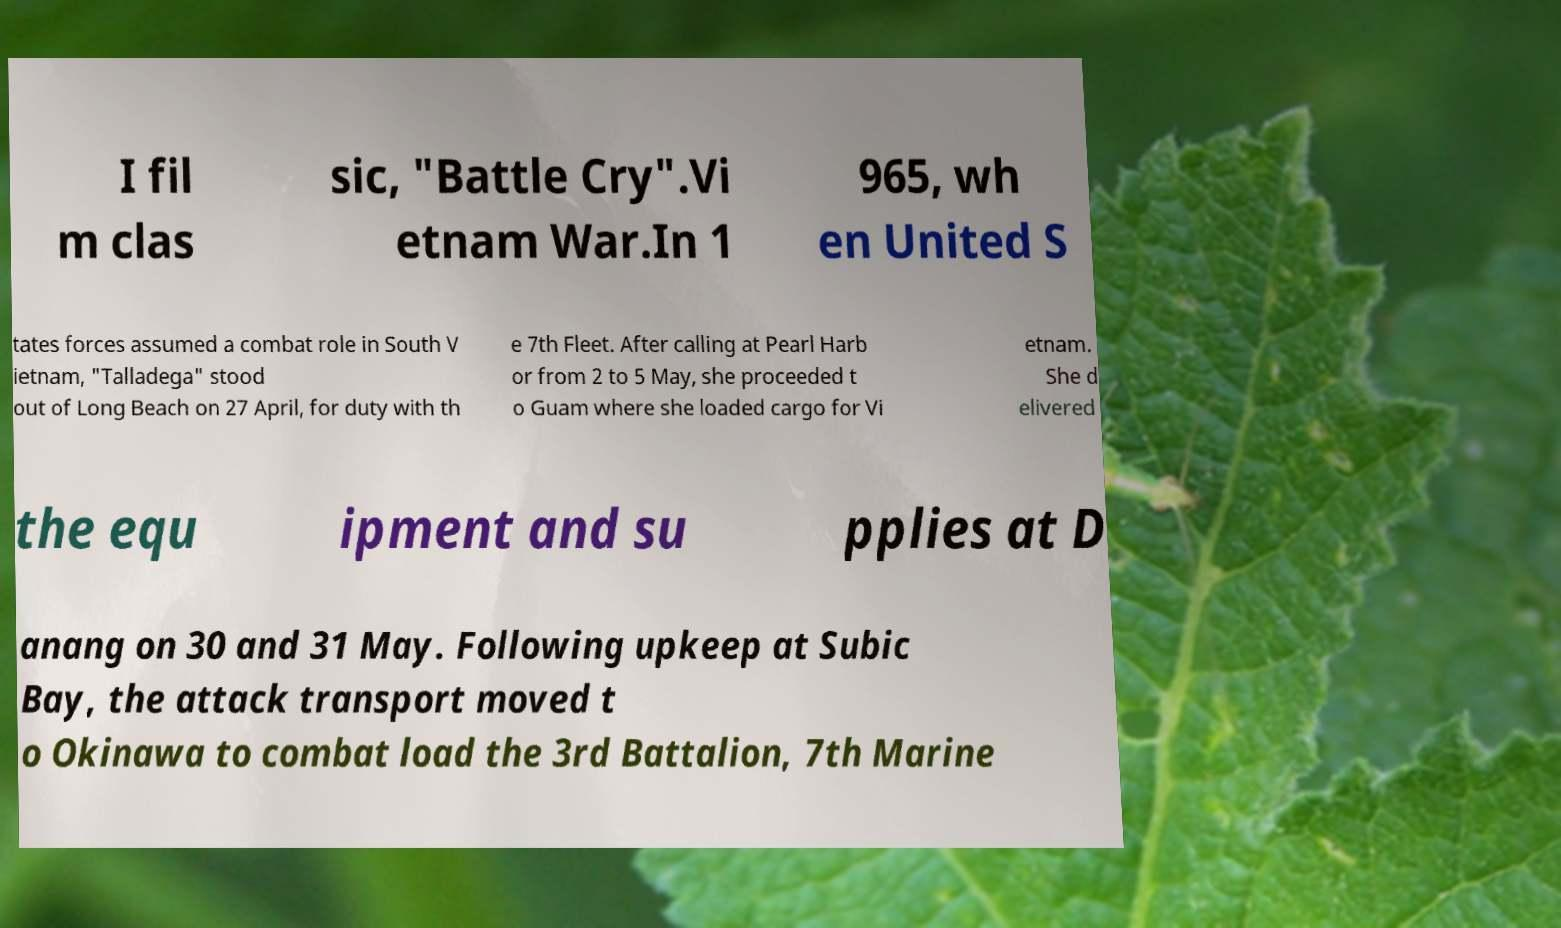Could you assist in decoding the text presented in this image and type it out clearly? I fil m clas sic, "Battle Cry".Vi etnam War.In 1 965, wh en United S tates forces assumed a combat role in South V ietnam, "Talladega" stood out of Long Beach on 27 April, for duty with th e 7th Fleet. After calling at Pearl Harb or from 2 to 5 May, she proceeded t o Guam where she loaded cargo for Vi etnam. She d elivered the equ ipment and su pplies at D anang on 30 and 31 May. Following upkeep at Subic Bay, the attack transport moved t o Okinawa to combat load the 3rd Battalion, 7th Marine 